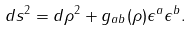<formula> <loc_0><loc_0><loc_500><loc_500>d s ^ { 2 } = d \rho ^ { 2 } + g _ { a b } ( \rho ) \epsilon ^ { a } \epsilon ^ { b } .</formula> 